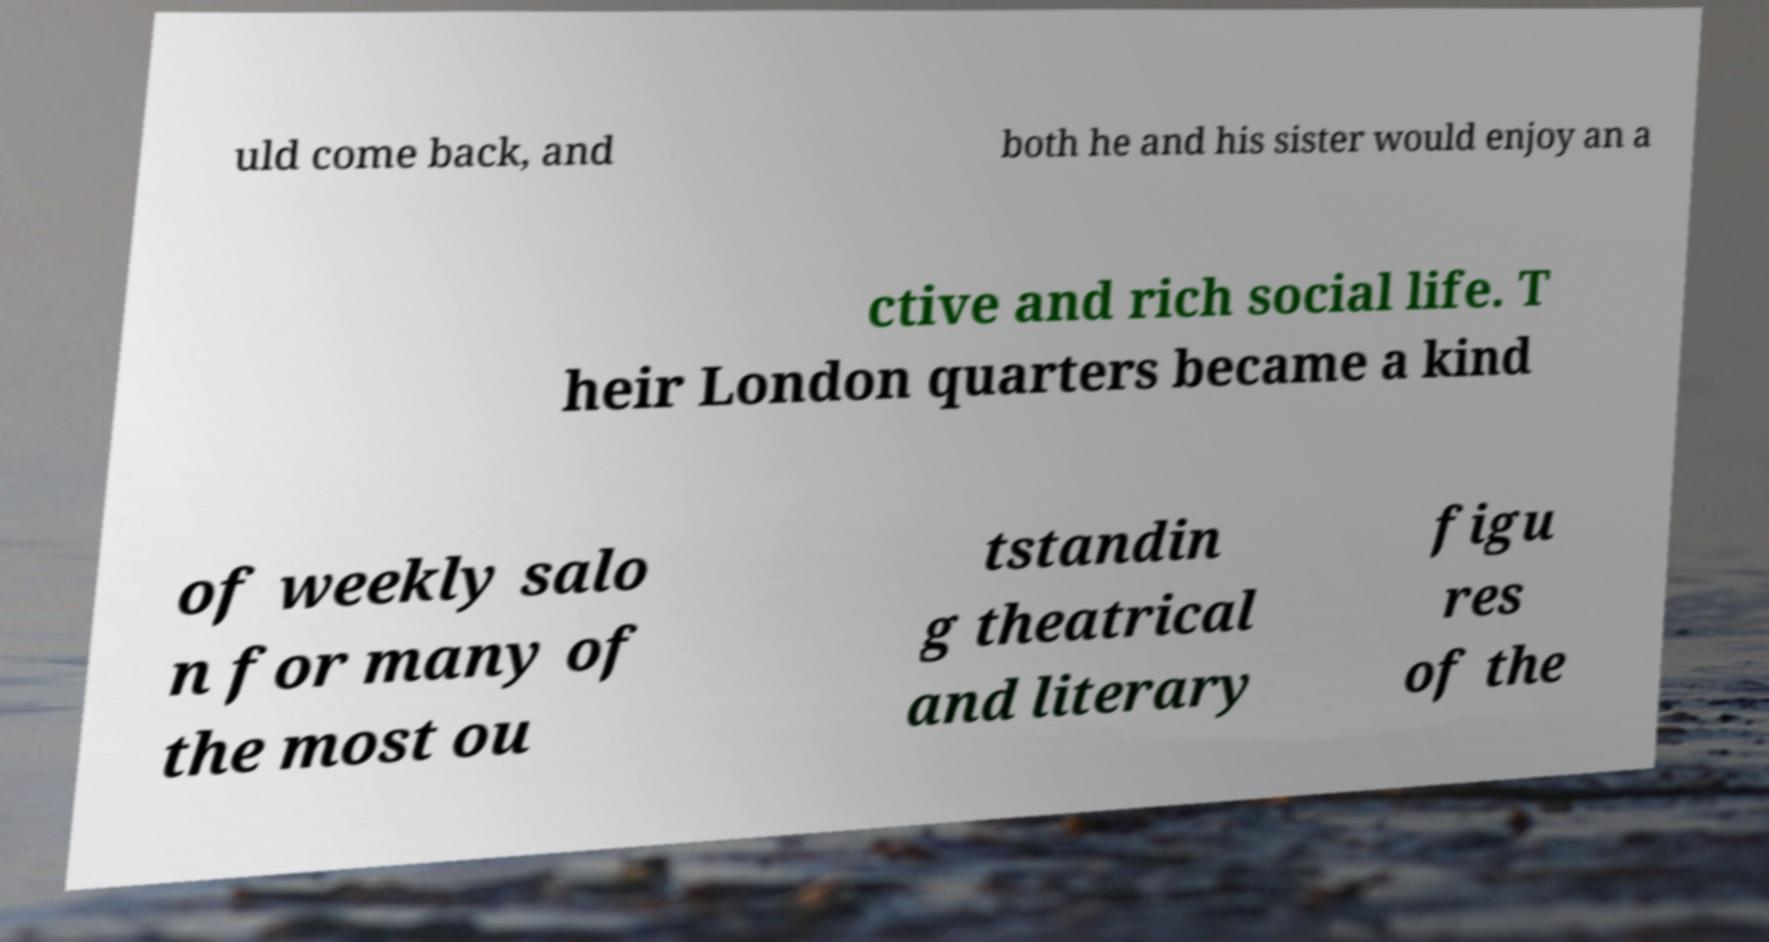For documentation purposes, I need the text within this image transcribed. Could you provide that? uld come back, and both he and his sister would enjoy an a ctive and rich social life. T heir London quarters became a kind of weekly salo n for many of the most ou tstandin g theatrical and literary figu res of the 